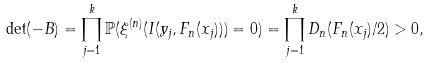<formula> <loc_0><loc_0><loc_500><loc_500>& \det ( - B ) = \prod _ { j = 1 } ^ { k } \mathbb { P } ( \xi ^ { ( n ) } ( I ( y _ { j } , F _ { n } ( x _ { j } ) ) ) = 0 ) = \prod _ { j = 1 } ^ { k } D _ { n } ( F _ { n } ( x _ { j } ) / 2 ) > 0 ,</formula> 